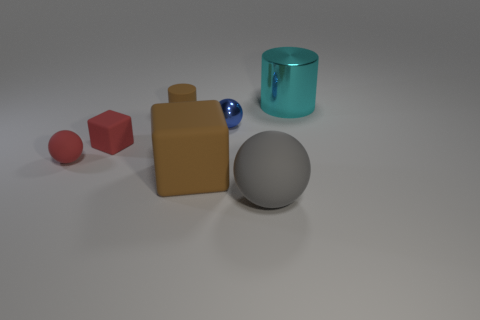Subtract all tiny matte spheres. How many spheres are left? 2 Add 2 tiny red things. How many objects exist? 9 Subtract all gray balls. How many balls are left? 2 Subtract 1 cylinders. How many cylinders are left? 1 Subtract all blocks. How many objects are left? 5 Subtract all green spheres. Subtract all yellow cylinders. How many spheres are left? 3 Subtract all yellow cubes. How many cyan cylinders are left? 1 Subtract all tiny rubber cylinders. Subtract all tiny cylinders. How many objects are left? 5 Add 6 blocks. How many blocks are left? 8 Add 7 red matte cubes. How many red matte cubes exist? 8 